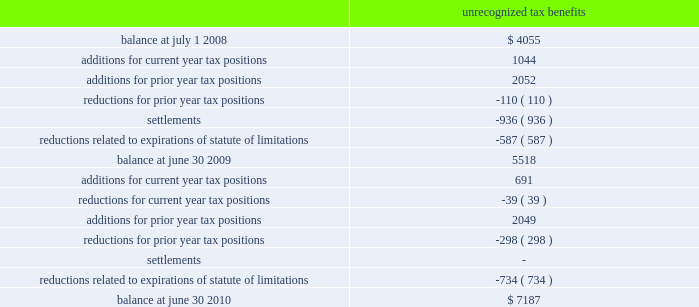48 2022 2010 annual report as part of the acquisition of gfsi , we acquired gross net operating loss ( 201cnol 201d ) carry forwards of $ 64431 ; of which , only $ 34592 are expected to be utilized due to the application of irc section 382 .
Separately , as of june 30 , 2010 , we had state nol carry forwards of $ 838 .
These losses have varying expiration dates , ranging from 2012 to 2029 .
Based on state tax rules which restrict our usage of these losses , we believe it is more likely than not that $ 306 of these losses will expire unutilized .
Accordingly , a valuation allowance of $ 306 has been recorded against these assets as of june 30 , 2010 .
The company paid income taxes of $ 42116 , $ 62965 , and $ 51709 in 2010 , 2009 , and 2008 , respectively .
At june 30 , 2009 , the company had $ 5518 of unrecognized tax benefits .
At june 30 , 2010 , the company had $ 7187 of unrecognized tax benefits , of which , $ 4989 , if recognized , would affect our effective tax rate .
We had accrued interest and penalties of $ 890 and $ 732 related to uncertain tax positions at june 30 , 2010 and 2009 , respectively .
A reconciliation of the unrecognized tax benefits for the years ended june 30 , 2010 and 2009 follows : unrecognized tax benefits .
During the fiscal year ended june 30 , 2010 , the internal revenue service commenced an examination of the company 2019s u.s .
Federal income tax returns for fiscal years ended june 2008 through 2009 .
The u.s .
Federal and state income tax returns for june 30 , 2007 and all subsequent years still remain subject to examination as of june 30 , 2010 under statute of limitations rules .
We anticipate potential changes resulting from the expiration of statutes of limitations of up to $ 965 could reduce the unrecognized tax benefits balance within twelve months of june 30 , note 8 : industry and supplier concentrations the company sells its products to banks , credit unions , and financial institutions throughout the united states and generally does not require collateral .
All billings to customers are due 30 days from date of billing .
Reserves ( which are insignificant at june 30 , 2010 , 2009 and 2008 ) are maintained for potential credit losses .
In addition , the company purchases most of its computer hardware and related maintenance for resale in relation to installation of jha software systems from two suppliers .
There are a limited number of hardware suppliers for these required items .
If these relationships were terminated , it could have a significant negative impact on the future operations of the company .
Note 9 : stock based compensation plans the company previously issued options to employees under the 1996 stock option plan ( 201c1996 sop 201d ) and currently issues options to outside directors under the 2005 non-qualified stock option plan ( 201c2005 nsop 201d ) .
1996 sop the 1996 sop was adopted by the company on october 29 , 1996 , for its employees .
Terms and vesting periods .
If the companies accounting policy were to include accrued interest and penalties in utp , what would the balance be as of at june 30 2010? 
Computations: (7187 + 890)
Answer: 8077.0. 